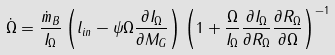<formula> <loc_0><loc_0><loc_500><loc_500>\dot { \Omega } = \frac { \dot { m } _ { B } } { I _ { \Omega } } \left ( l _ { i n } - \psi \Omega \frac { \partial I _ { \Omega } } { \partial M _ { G } } \right ) \left ( 1 + \frac { \Omega } { I _ { \Omega } } \frac { \partial I _ { \Omega } } { \partial R _ { \Omega } } \frac { \partial R _ { \Omega } } { \partial \Omega } \right ) ^ { - 1 }</formula> 